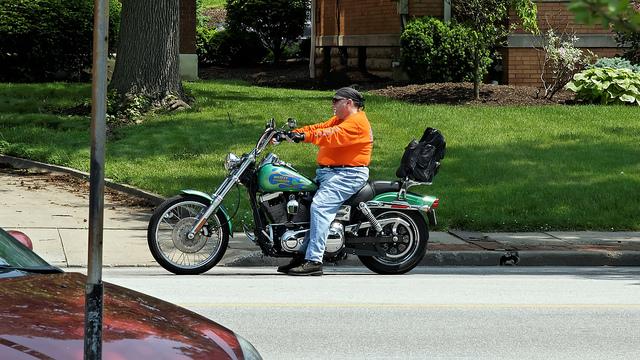Does this motorcycle have room for another person?
Short answer required. Yes. What kind of shoes is the man wearing?
Concise answer only. Boots. What color is the motorcycle?
Keep it brief. Green. How many people on the motorcycle?
Write a very short answer. 1. What color is the person's jacket?
Concise answer only. Orange. Is the motorcycle moving?
Quick response, please. No. How many motorcycles are pictured?
Give a very brief answer. 1. 